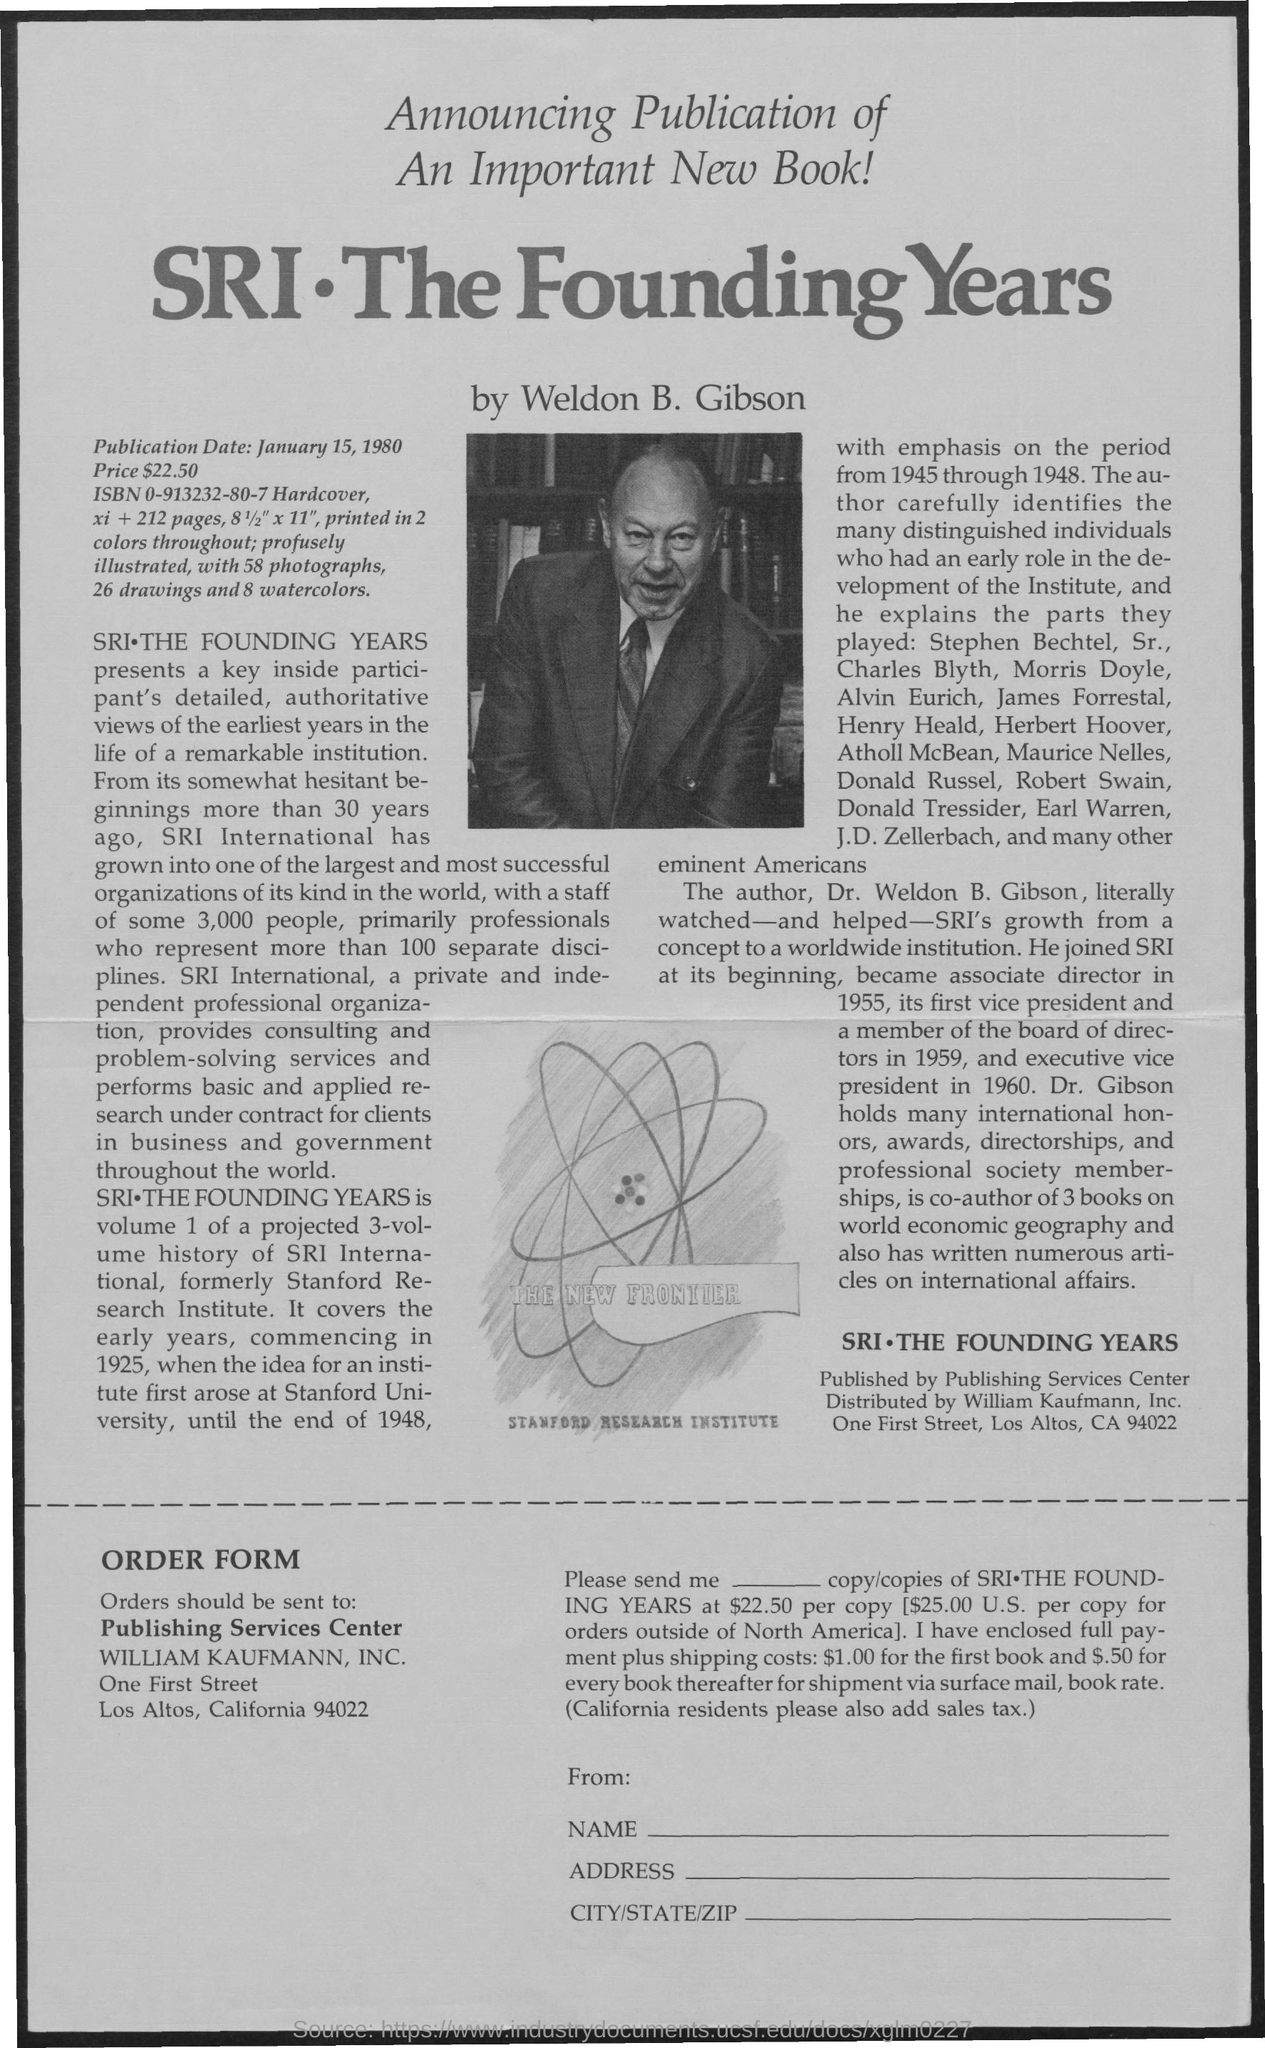Give some essential details in this illustration. The publication date is January 15, 1980. 